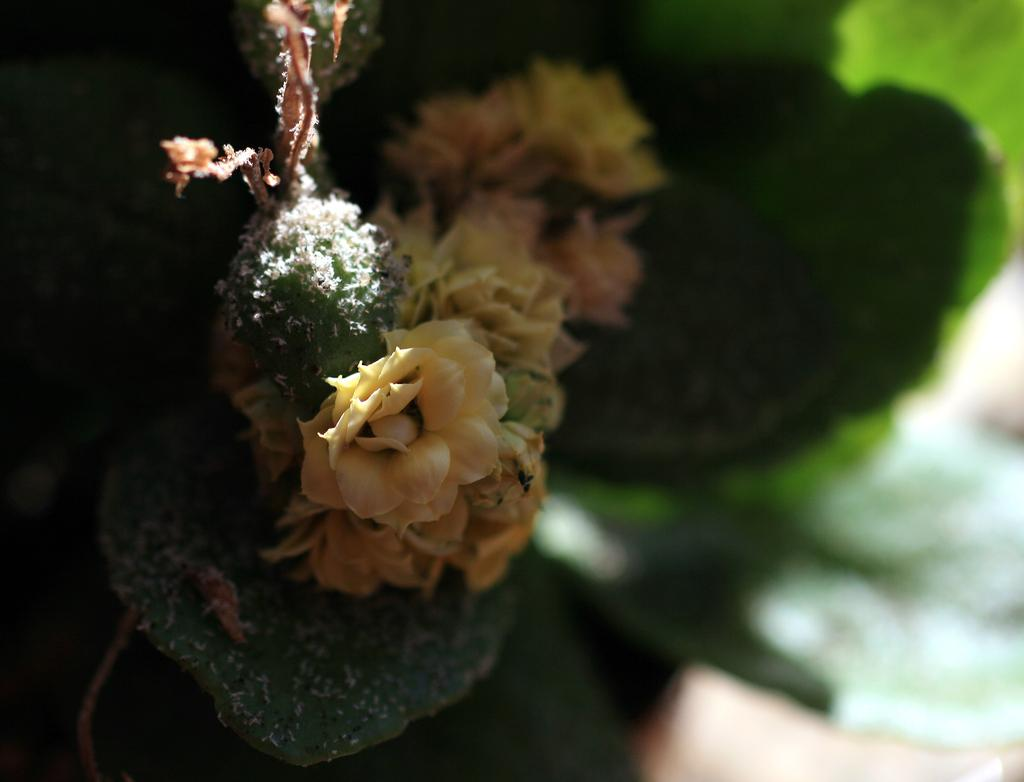What type of plant is visible in the image? There is a plant with flowers in the image. What can be seen on the right side of the image? There is a blurred image on the right side of the image. How does the plant compare to the other plants in the competition? There is no competition mentioned in the image, so it is not possible to compare the plant to other plants. 